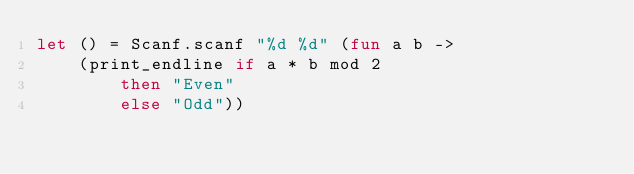<code> <loc_0><loc_0><loc_500><loc_500><_OCaml_>let () = Scanf.scanf "%d %d" (fun a b ->
	(print_endline if a * b mod 2 
    	then "Even"
        else "Odd"))</code> 